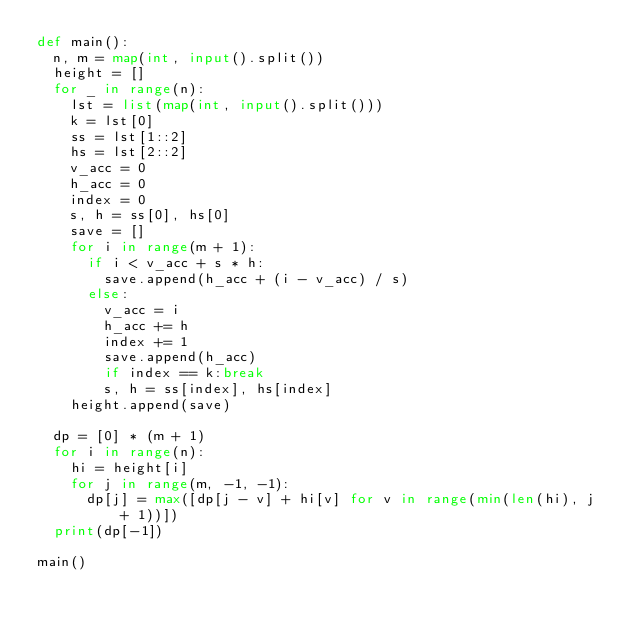<code> <loc_0><loc_0><loc_500><loc_500><_Python_>def main():
  n, m = map(int, input().split())
  height = []
  for _ in range(n):
    lst = list(map(int, input().split()))
    k = lst[0]
    ss = lst[1::2]
    hs = lst[2::2]
    v_acc = 0
    h_acc = 0
    index = 0
    s, h = ss[0], hs[0]
    save = []
    for i in range(m + 1):
      if i < v_acc + s * h:
        save.append(h_acc + (i - v_acc) / s)
      else:
        v_acc = i
        h_acc += h
        index += 1
        save.append(h_acc)
        if index == k:break
        s, h = ss[index], hs[index]
    height.append(save)
  
  dp = [0] * (m + 1)
  for i in range(n):
    hi = height[i]
    for j in range(m, -1, -1):
      dp[j] = max([dp[j - v] + hi[v] for v in range(min(len(hi), j + 1))])
  print(dp[-1])

main()
</code> 